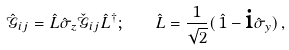<formula> <loc_0><loc_0><loc_500><loc_500>\hat { \mathcal { G } } _ { i j } = \hat { L } \hat { \sigma } _ { z } \check { \mathcal { G } } _ { i j } \hat { L } ^ { \dagger } ; \quad \hat { L } = \frac { 1 } { \sqrt { 2 } } ( \, \hat { 1 } - \text {i} \hat { \sigma } _ { y } ) \, ,</formula> 